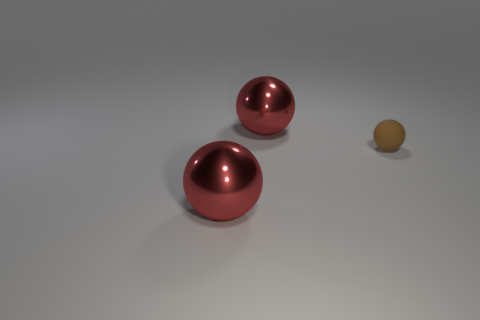How many other objects are there of the same material as the tiny ball?
Your answer should be very brief. 0. Is there anything else that is the same shape as the brown matte object?
Keep it short and to the point. Yes. Is the number of things less than the number of small brown matte objects?
Offer a terse response. No. There is a large red metal object in front of the small sphere; are there any large red metal balls that are to the left of it?
Offer a very short reply. No. How many things are either tiny purple objects or big red spheres?
Provide a succinct answer. 2. Does the red object that is behind the tiny rubber sphere have the same material as the brown sphere?
Make the answer very short. No. How many objects are red objects or big things that are on the left side of the brown matte ball?
Keep it short and to the point. 2. What number of brown matte balls are there?
Give a very brief answer. 1. There is a big sphere that is in front of the rubber object; does it have the same color as the ball that is behind the small brown matte object?
Offer a terse response. Yes. How many metallic balls are to the left of the tiny sphere?
Your answer should be compact. 2. 